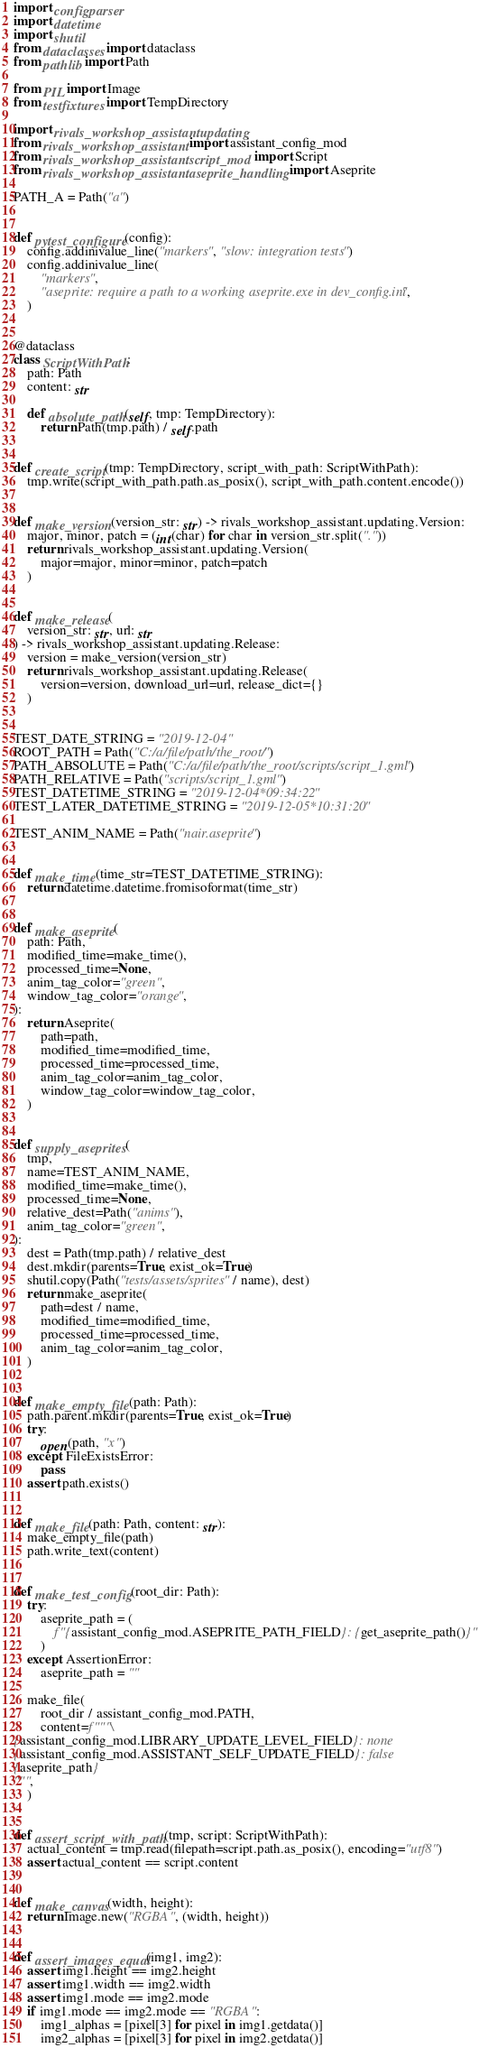<code> <loc_0><loc_0><loc_500><loc_500><_Python_>import configparser
import datetime
import shutil
from dataclasses import dataclass
from pathlib import Path

from PIL import Image
from testfixtures import TempDirectory

import rivals_workshop_assistant.updating
from rivals_workshop_assistant import assistant_config_mod
from rivals_workshop_assistant.script_mod import Script
from rivals_workshop_assistant.aseprite_handling import Aseprite

PATH_A = Path("a")


def pytest_configure(config):
    config.addinivalue_line("markers", "slow: integration tests")
    config.addinivalue_line(
        "markers",
        "aseprite: require a path to a working aseprite.exe in dev_config.ini",
    )


@dataclass
class ScriptWithPath:
    path: Path
    content: str

    def absolute_path(self, tmp: TempDirectory):
        return Path(tmp.path) / self.path


def create_script(tmp: TempDirectory, script_with_path: ScriptWithPath):
    tmp.write(script_with_path.path.as_posix(), script_with_path.content.encode())


def make_version(version_str: str) -> rivals_workshop_assistant.updating.Version:
    major, minor, patch = (int(char) for char in version_str.split("."))
    return rivals_workshop_assistant.updating.Version(
        major=major, minor=minor, patch=patch
    )


def make_release(
    version_str: str, url: str
) -> rivals_workshop_assistant.updating.Release:
    version = make_version(version_str)
    return rivals_workshop_assistant.updating.Release(
        version=version, download_url=url, release_dict={}
    )


TEST_DATE_STRING = "2019-12-04"
ROOT_PATH = Path("C:/a/file/path/the_root/")
PATH_ABSOLUTE = Path("C:/a/file/path/the_root/scripts/script_1.gml")
PATH_RELATIVE = Path("scripts/script_1.gml")
TEST_DATETIME_STRING = "2019-12-04*09:34:22"
TEST_LATER_DATETIME_STRING = "2019-12-05*10:31:20"

TEST_ANIM_NAME = Path("nair.aseprite")


def make_time(time_str=TEST_DATETIME_STRING):
    return datetime.datetime.fromisoformat(time_str)


def make_aseprite(
    path: Path,
    modified_time=make_time(),
    processed_time=None,
    anim_tag_color="green",
    window_tag_color="orange",
):
    return Aseprite(
        path=path,
        modified_time=modified_time,
        processed_time=processed_time,
        anim_tag_color=anim_tag_color,
        window_tag_color=window_tag_color,
    )


def supply_aseprites(
    tmp,
    name=TEST_ANIM_NAME,
    modified_time=make_time(),
    processed_time=None,
    relative_dest=Path("anims"),
    anim_tag_color="green",
):
    dest = Path(tmp.path) / relative_dest
    dest.mkdir(parents=True, exist_ok=True)
    shutil.copy(Path("tests/assets/sprites" / name), dest)
    return make_aseprite(
        path=dest / name,
        modified_time=modified_time,
        processed_time=processed_time,
        anim_tag_color=anim_tag_color,
    )


def make_empty_file(path: Path):
    path.parent.mkdir(parents=True, exist_ok=True)
    try:
        open(path, "x")
    except FileExistsError:
        pass
    assert path.exists()


def make_file(path: Path, content: str):
    make_empty_file(path)
    path.write_text(content)


def make_test_config(root_dir: Path):
    try:
        aseprite_path = (
            f"{assistant_config_mod.ASEPRITE_PATH_FIELD}: {get_aseprite_path()}"
        )
    except AssertionError:
        aseprite_path = ""

    make_file(
        root_dir / assistant_config_mod.PATH,
        content=f"""\
{assistant_config_mod.LIBRARY_UPDATE_LEVEL_FIELD}: none
{assistant_config_mod.ASSISTANT_SELF_UPDATE_FIELD}: false
{aseprite_path}
""",
    )


def assert_script_with_path(tmp, script: ScriptWithPath):
    actual_content = tmp.read(filepath=script.path.as_posix(), encoding="utf8")
    assert actual_content == script.content


def make_canvas(width, height):
    return Image.new("RGBA", (width, height))


def assert_images_equal(img1, img2):
    assert img1.height == img2.height
    assert img1.width == img2.width
    assert img1.mode == img2.mode
    if img1.mode == img2.mode == "RGBA":
        img1_alphas = [pixel[3] for pixel in img1.getdata()]
        img2_alphas = [pixel[3] for pixel in img2.getdata()]</code> 